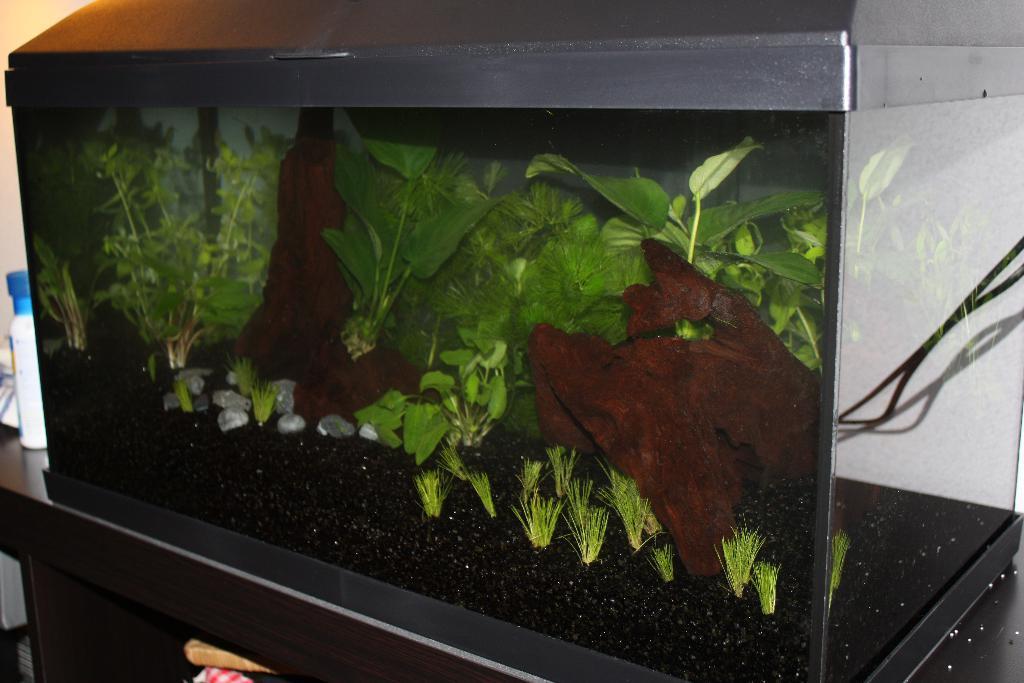How would you summarize this image in a sentence or two? In this image I can see a aquarium. I can see plants,grass,stones and black sand. It is on the table. 